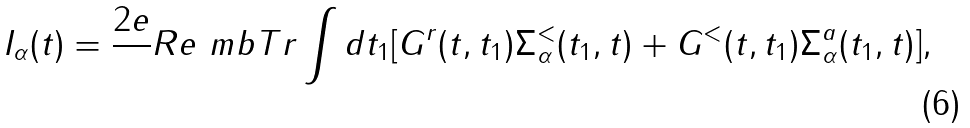<formula> <loc_0><loc_0><loc_500><loc_500>I _ { \alpha } ( t ) = \frac { 2 e } { } R e \ m b { T r } \int d t _ { 1 } [ G ^ { r } ( t , t _ { 1 } ) \Sigma ^ { < } _ { \alpha } ( t _ { 1 } , t ) + G ^ { < } ( t , t _ { 1 } ) \Sigma ^ { a } _ { \alpha } ( t _ { 1 } , t ) ] ,</formula> 